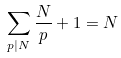Convert formula to latex. <formula><loc_0><loc_0><loc_500><loc_500>\sum _ { p | N } \frac { N } { p } + 1 = N</formula> 